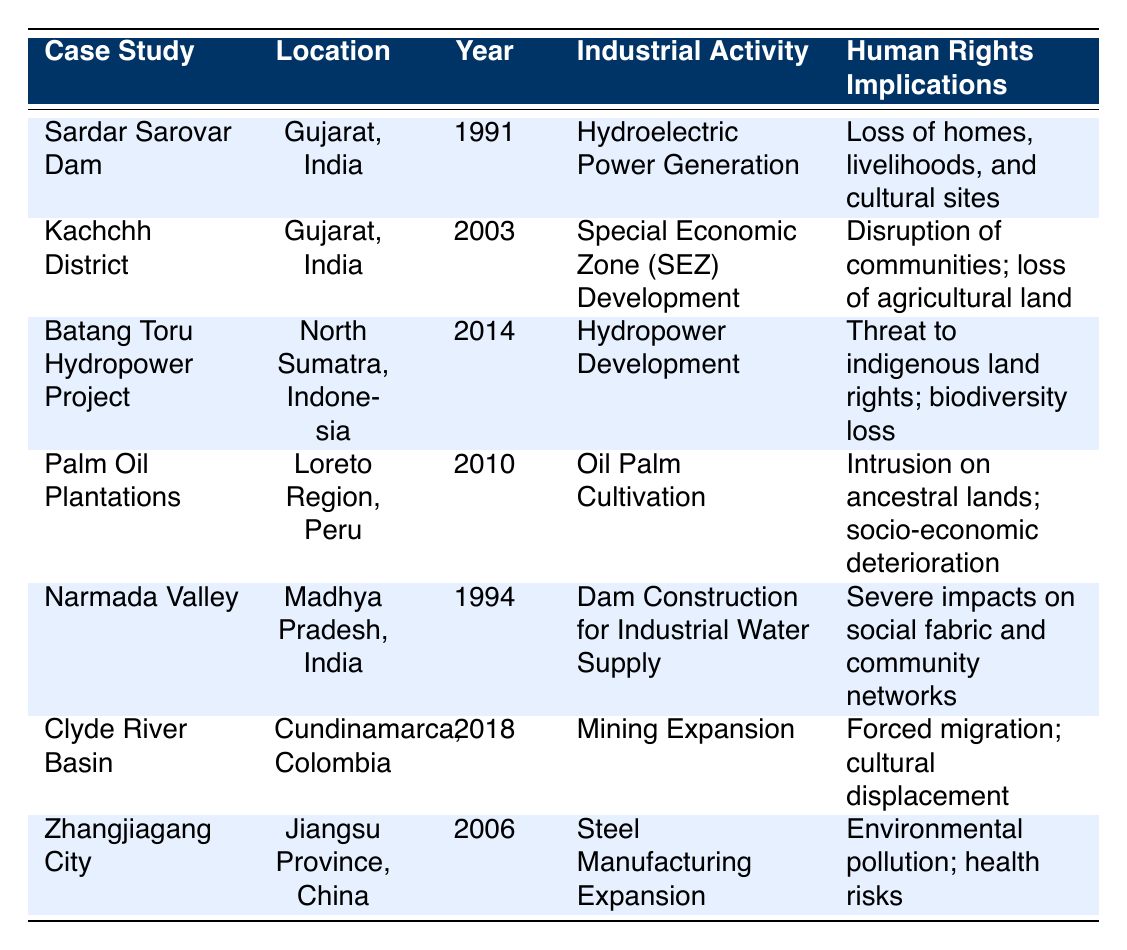What is the total population displaced by the case studies listed? To find the total population displaced, I will sum the populations displaced from each case study: 320000 + 10000 + 12000 + 5000 + 500000 + 2000 + 18000 = 853000.
Answer: 853000 Which case study has the largest population displacement? By examining the population displaced in each case study, I see that the Narmada Valley case study reports the largest number at 500000.
Answer: Narmada Valley How many case studies involved hydropower development? A quick review of the case studies reveals that there are two cases that involved hydropower development: Sardar Sarovar Dam and Batang Toru Hydropower Project.
Answer: 2 Did any of the case studies report government responses that included compensation? Examining the table, both the Sardar Sarovar Dam and Batang Toru Hydropower Project reported that compensation was provided. Therefore, the answer is yes.
Answer: Yes What is the average population displaced across all case studies? First, I calculate the total displaced population (853000) as previously calculated. Then, I divide this by the number of case studies, which is 7: 853000 / 7 = 121857.14. Rounding to the nearest integer gives 121857.
Answer: 121857 Which case study's human rights implications mention loss of agricultural land? I look through the human rights implications described and find that the Kachchh District case study specifies loss of agricultural land.
Answer: Kachchh District Is the majority of the population displaced from case studies in India? Analyzing the data points, I find that 3 out of the 7 total case studies are from India (Sardar Sarovar, Kachchh District, and Narmada Valley), meaning the majority is indeed from India.
Answer: Yes What year experienced the earliest displacement event in the case studies listed? By reviewing the years provided, I see that the Sardar Sarovar Dam case study occurred in 1991, which is the earliest year mentioned.
Answer: 1991 How many case studies resulted in cultural displacement? Upon checking the human rights implications, both the Clyde River Basin and Palm Oil Plantations case studies mention cultural displacement. Therefore, I find that there are 2 case studies.
Answer: 2 What was the major industrial activity associated with the Zhangjiagang City case study? The table lists the major industrial activity for Zhangjiagang City as steel manufacturing expansion.
Answer: Steel Manufacturing Expansion 